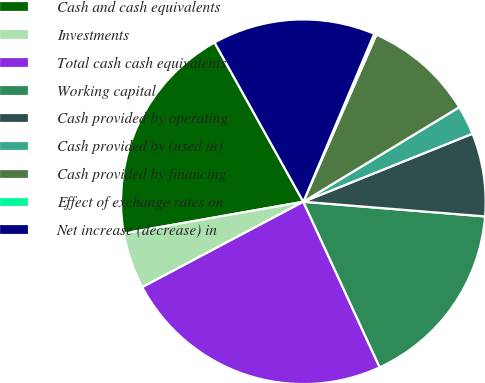<chart> <loc_0><loc_0><loc_500><loc_500><pie_chart><fcel>Cash and cash equivalents<fcel>Investments<fcel>Total cash cash equivalents<fcel>Working capital<fcel>Cash provided by operating<fcel>Cash provided by (used in)<fcel>Cash provided by financing<fcel>Effect of exchange rates on<fcel>Net increase (decrease) in<nl><fcel>19.69%<fcel>4.98%<fcel>24.12%<fcel>16.84%<fcel>7.37%<fcel>2.59%<fcel>9.77%<fcel>0.2%<fcel>14.45%<nl></chart> 